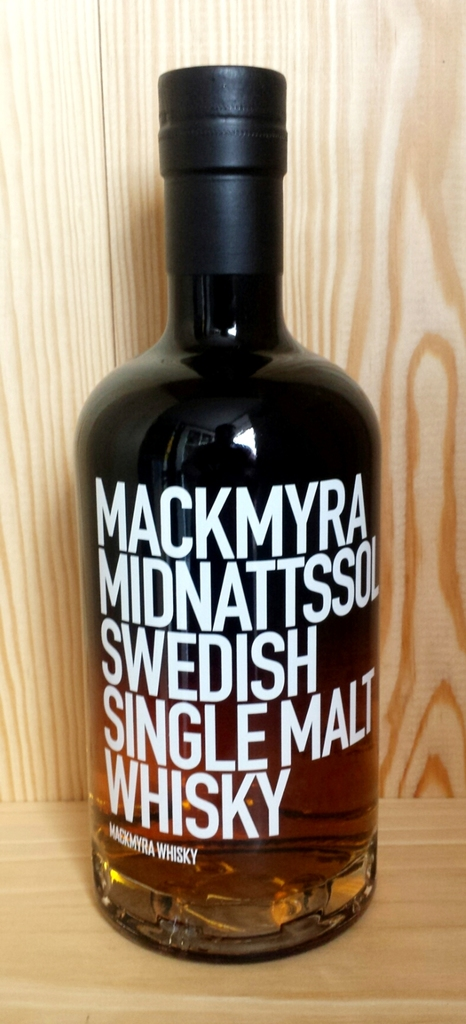What can you tell me about the brand Mackmyra mentioned on the whisky bottle? Mackmyra is a pioneering Swedish whisky distillery, established in 1999. It's known for crafting innovative and distinctively Swedish whiskies, often using local ingredients and experimenting with different aging techniques, like using Swedish oak. The distillery has garnered international acclaim for its unique approach to whisky making. 